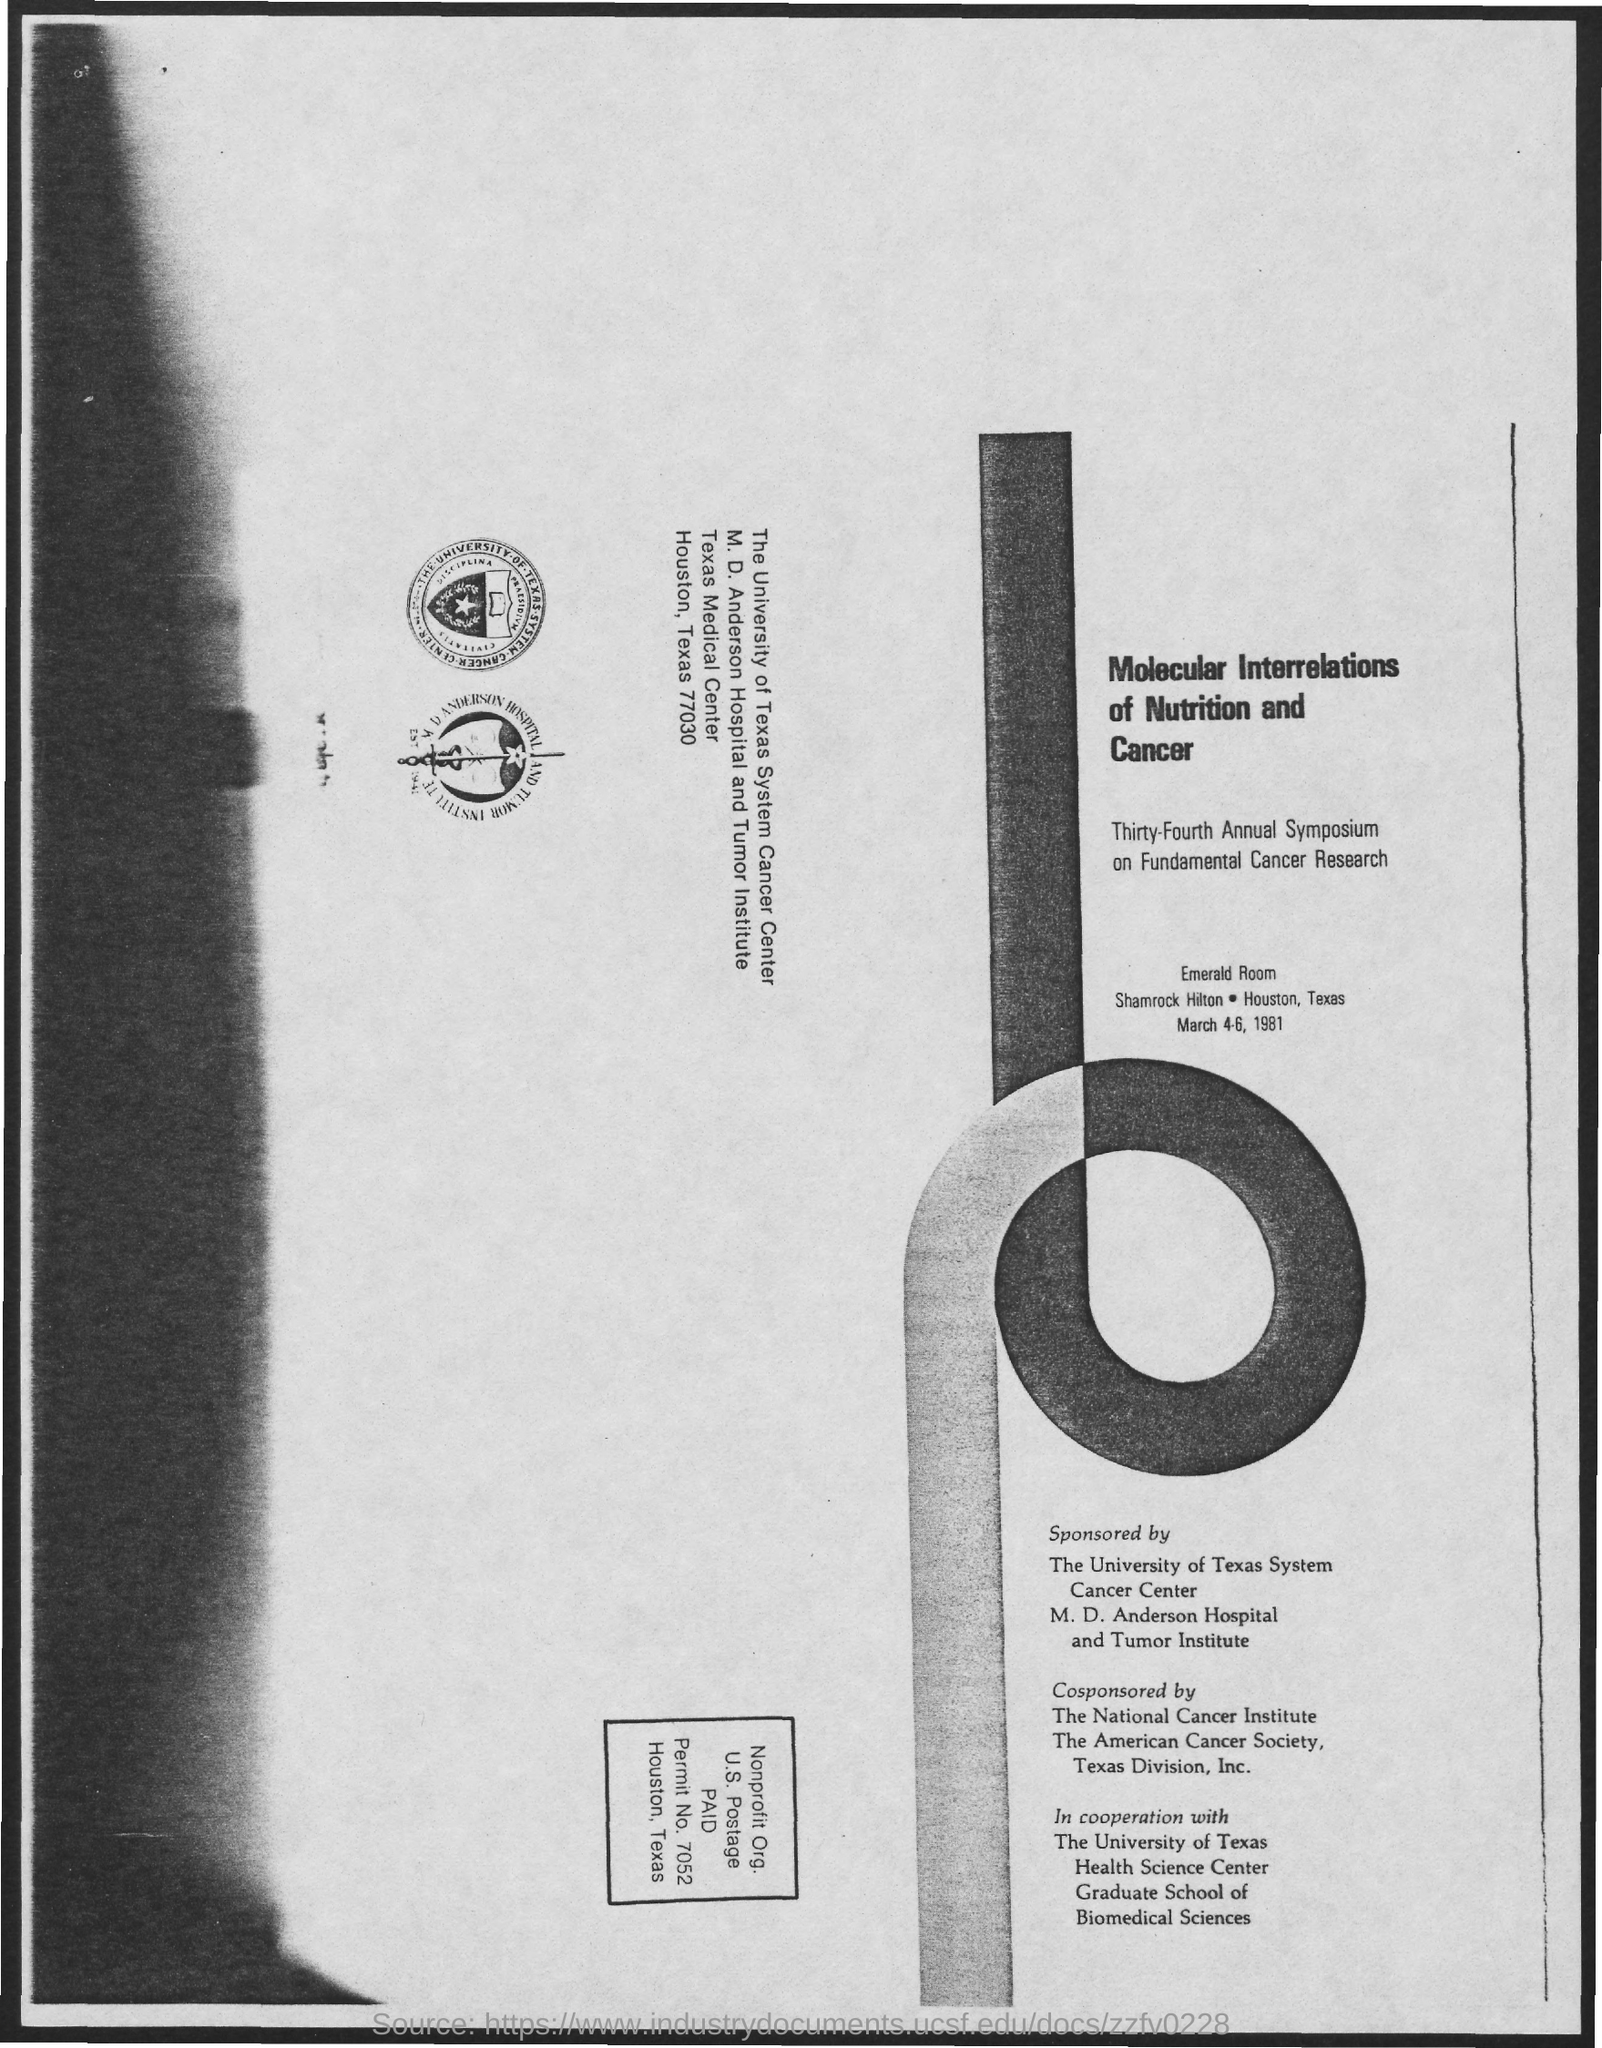What is the name of the room mentioned in the given page ?
Provide a succinct answer. Emerald room. Which molecular interrelations was mentioned in the given page ?
Keep it short and to the point. Molecular interrelations of nutrition and cancer. 